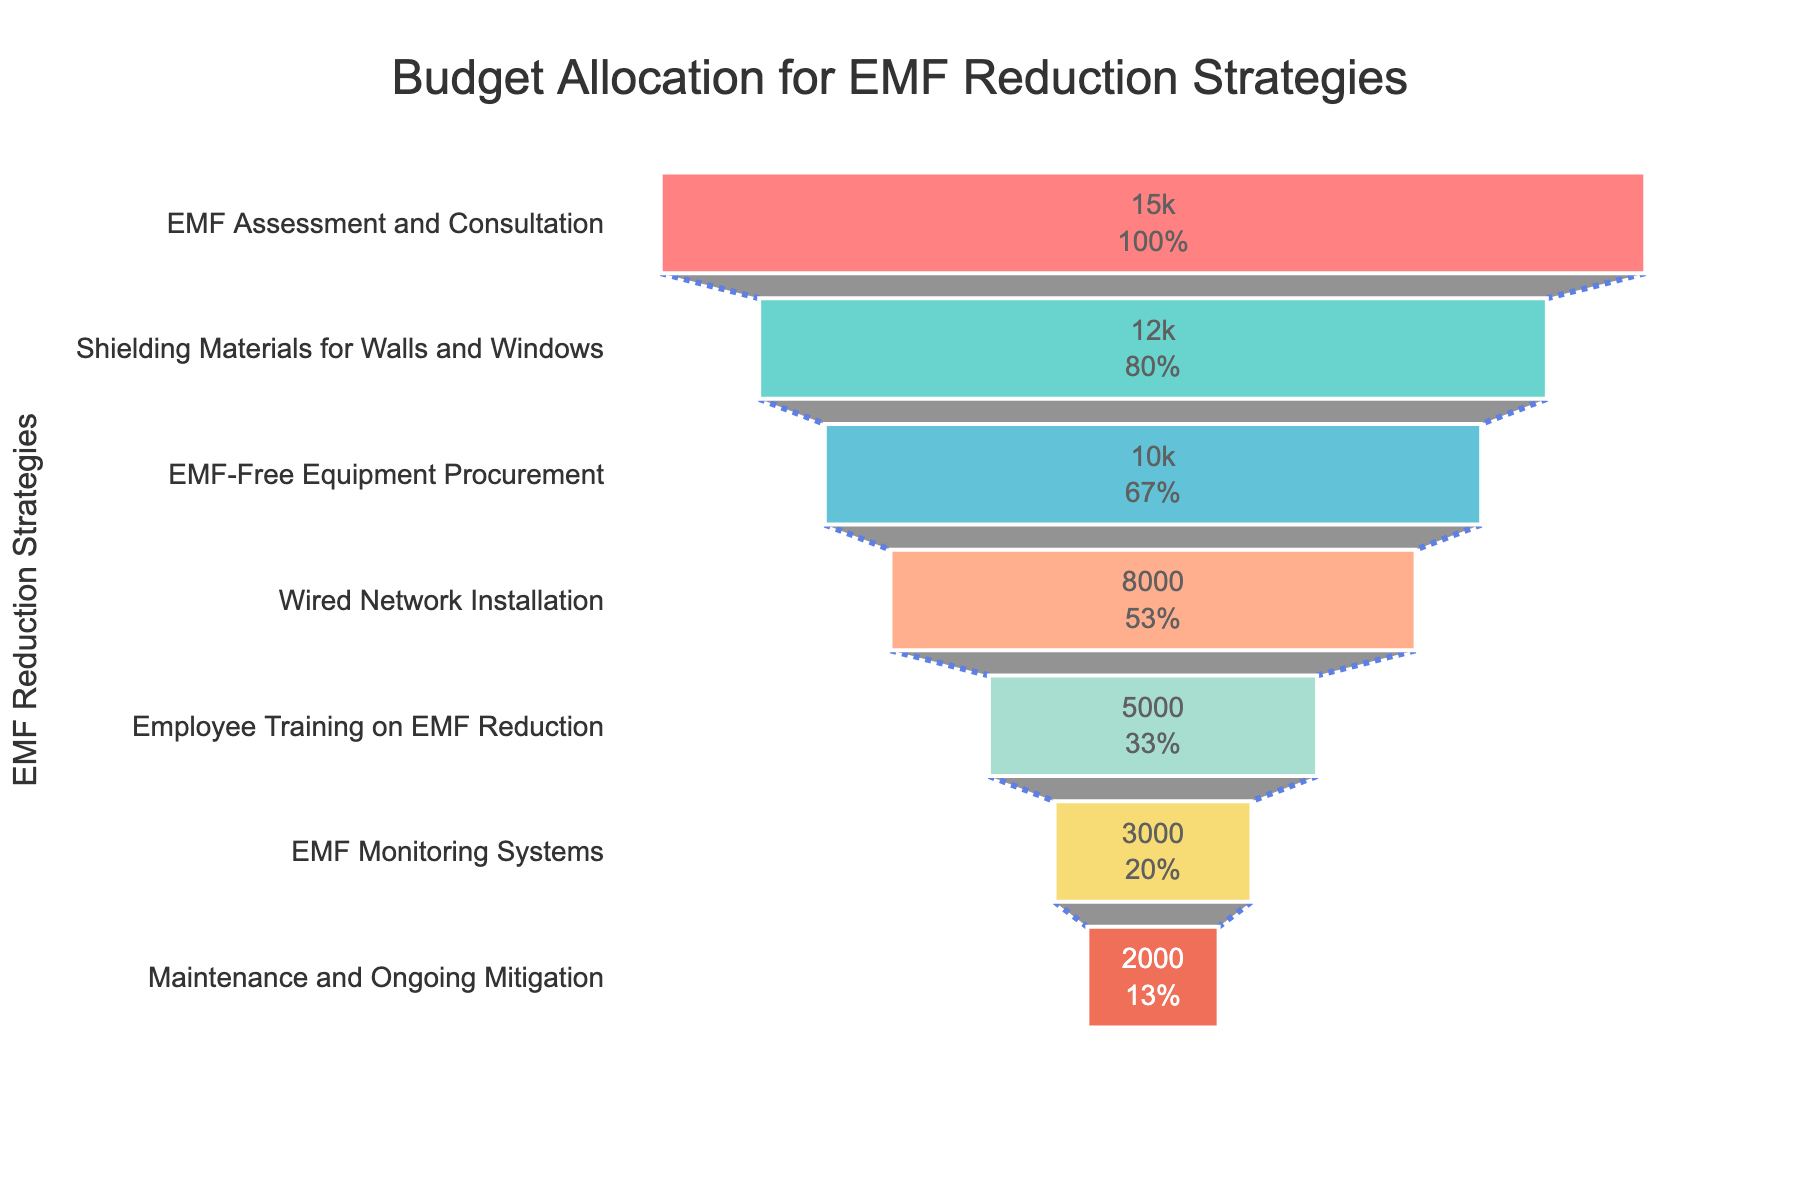What is the title of the figure? The title is located at the top of the figure and provides a summary of the chart's purpose. It states the subject of the visualization.
Answer: Budget Allocation for EMF Reduction Strategies How many EMF reduction strategies are shown in the funnel chart? Count the number of unique stages listed in the figure. Each stage represents an EMF reduction strategy.
Answer: 7 Which EMF reduction strategy has the highest budget allocation? Look at the top stage in the funnel chart, as it represents the strategy with the largest budget allocation.
Answer: EMF Assessment and Consultation What's the combined budget allocation for EMF-Free Equipment Procurement and Wired Network Installation? Identify the budget values for these two stages, then sum them up. EMF-Free Equipment Procurement has $10,000, and Wired Network Installation has $8,000. $10,000 + $8,000 = $18,000.
Answer: $18,000 What is the budget allocation for the Employee Training on EMF Reduction strategy? Find the corresponding stage in the funnel chart and note its budget allocation value.
Answer: $5,000 Which stage has the smallest budget allocation, and what is its value? Look at the bottom stage of the funnel chart, which has the lowest budget allocation, and note its amount.
Answer: Maintenance and Ongoing Mitigation, $2,000 By what percentage does the budget for Shielding Materials for Walls and Windows differ from EMF-Free Equipment Procurement? First, find the values for both stages. Shielding Materials for Walls and Windows is $12,000 and EMF-Free Equipment Procurement is $10,000. The difference is $12,000 - $10,000 = $2,000. The percentage difference is ($2,000 / $10,000) * 100% = 20%.
Answer: 20% What proportion of the total budget is allocated to EMF Monitoring Systems? Sum the budgets for all stages to find the total budget. Add the values: $15,000 + $12,000 + $10,000 + $8,000 + $5,000 + $3,000 + $2,000 = $55,000. The proportion for EMF Monitoring Systems is ($3,000 / $55,000) * 100% = ~5.45%.
Answer: ~5.45% What is the cumulative budget allocation for the first three strategies in the funnel chart? Sum the budget allocations for the first three stages: EMF Assessment and Consultation ($15,000), Shielding Materials for Walls and Windows ($12,000), and EMF-Free Equipment Procurement ($10,000). Total = $15,000 + $12,000 + $10,000 = $37,000.
Answer: $37,000 Which strategy has a higher budget allocation: Employee Training on EMF Reduction or EMF Monitoring Systems? Compare the budget values. Employee Training on EMF Reduction is $5,000 and EMF Monitoring Systems is $3,000. Employee Training on EMF Reduction has a higher value.
Answer: Employee Training on EMF Reduction 